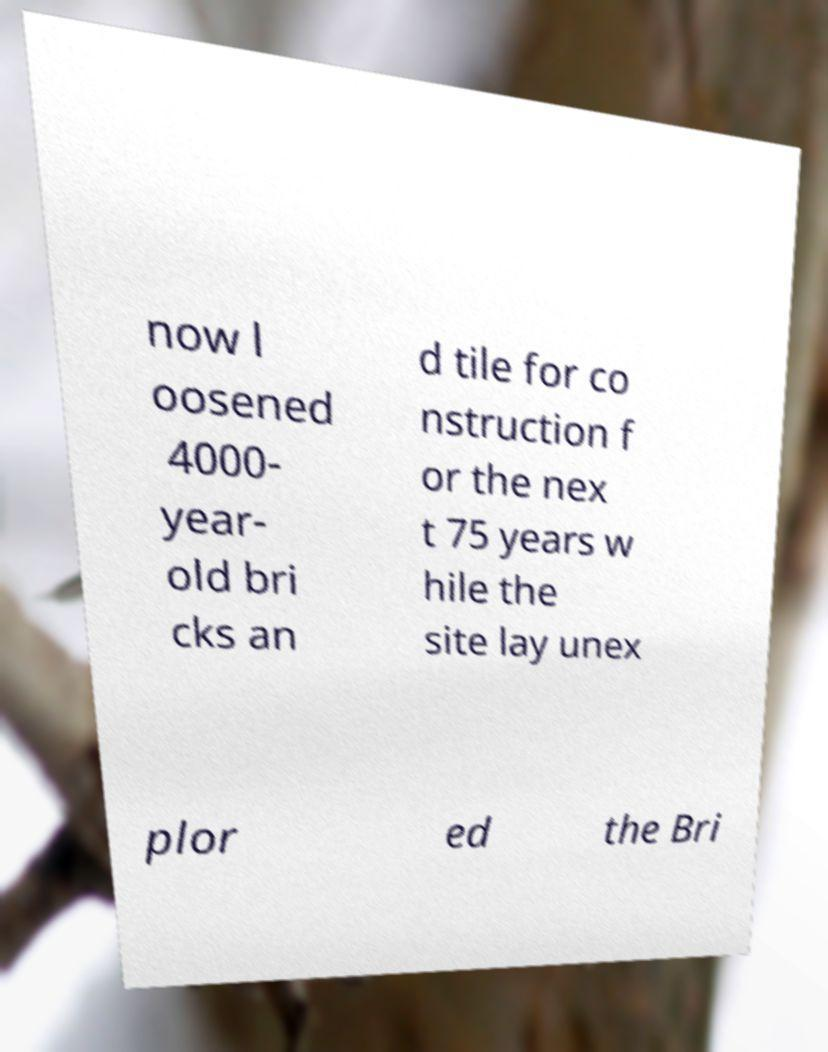Could you extract and type out the text from this image? now l oosened 4000- year- old bri cks an d tile for co nstruction f or the nex t 75 years w hile the site lay unex plor ed the Bri 